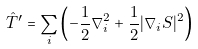Convert formula to latex. <formula><loc_0><loc_0><loc_500><loc_500>\hat { T } ^ { \prime } = \sum _ { i } \left ( - \frac { 1 } { 2 } \nabla _ { i } ^ { 2 } + \frac { 1 } { 2 } | { \nabla } _ { i } S | ^ { 2 } \right )</formula> 